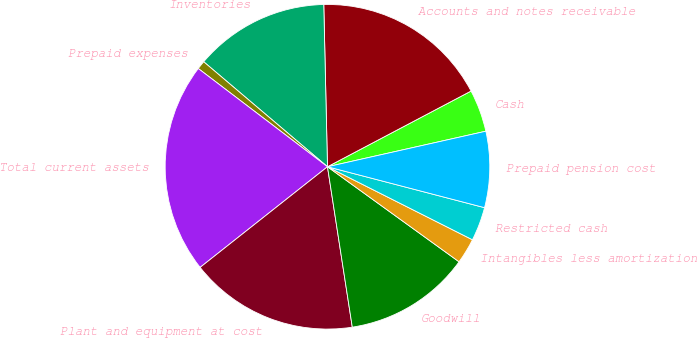Convert chart to OTSL. <chart><loc_0><loc_0><loc_500><loc_500><pie_chart><fcel>Cash<fcel>Accounts and notes receivable<fcel>Inventories<fcel>Prepaid expenses<fcel>Total current assets<fcel>Plant and equipment at cost<fcel>Goodwill<fcel>Intangibles less amortization<fcel>Restricted cash<fcel>Prepaid pension cost<nl><fcel>4.21%<fcel>17.64%<fcel>13.44%<fcel>0.85%<fcel>20.99%<fcel>16.8%<fcel>12.6%<fcel>2.53%<fcel>3.37%<fcel>7.57%<nl></chart> 